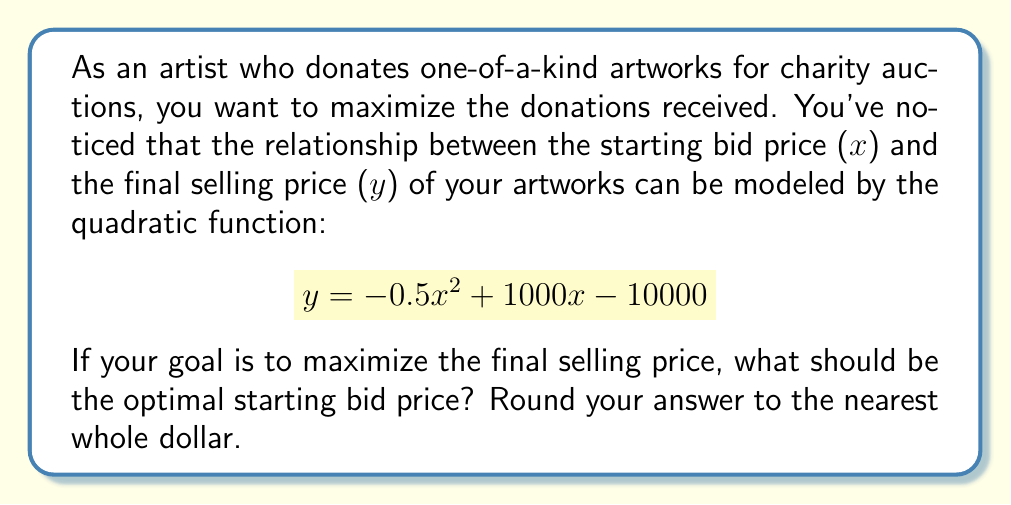Give your solution to this math problem. To find the optimal starting bid price that maximizes the final selling price, we need to find the vertex of the parabola described by the given quadratic function. The vertex represents the highest point of the parabola, which in this case, is the maximum selling price.

1) The quadratic function is in the form:
   $$y = ax^2 + bx + c$$
   where $a = -0.5$, $b = 1000$, and $c = -10000$

2) For a quadratic function, the x-coordinate of the vertex is given by:
   $$x = -\frac{b}{2a}$$

3) Substituting our values:
   $$x = -\frac{1000}{2(-0.5)} = \frac{1000}{-1} = 1000$$

4) To verify this is a maximum (not a minimum), we check that $a < 0$, which it is $(-0.5 < 0)$.

5) Therefore, the optimal starting bid price is $1000.

6) To find the maximum selling price, we substitute $x = 1000$ into the original equation:
   $$y = -0.5(1000)^2 + 1000(1000) - 10000$$
   $$y = -500000 + 1000000 - 10000 = 490000$$

Thus, the maximum selling price is $490,000.
Answer: The optimal starting bid price is $1000. 